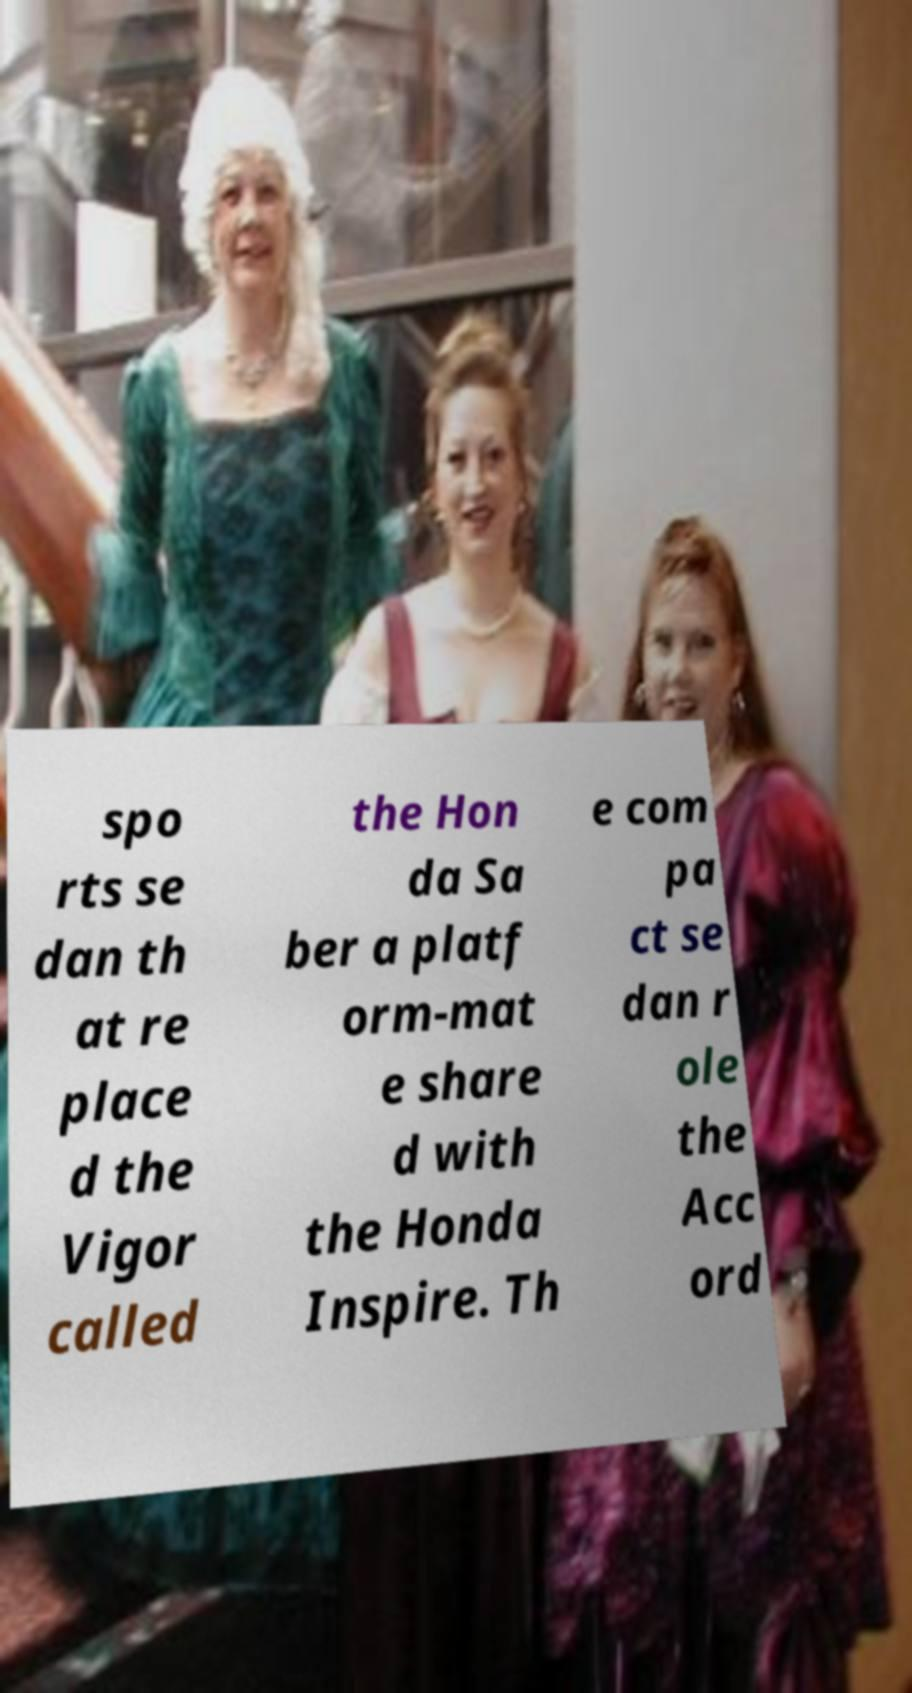I need the written content from this picture converted into text. Can you do that? spo rts se dan th at re place d the Vigor called the Hon da Sa ber a platf orm-mat e share d with the Honda Inspire. Th e com pa ct se dan r ole the Acc ord 